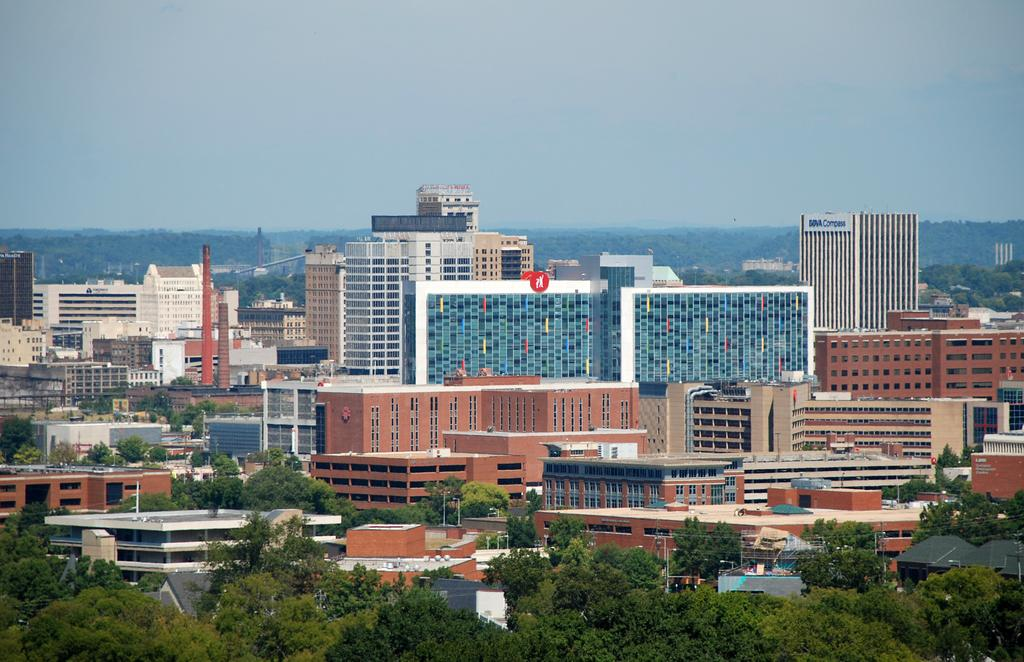What type of landscape is depicted in the image? The image contains a view of the city. What is a common feature of the buildings in the city? There are many glass buildings in the image. What type of vegetation can be seen in the image? There are trees in the front side of the image. How many veins can be seen running through the trees in the image? There are no veins visible in the image, as veins are a part of living organisms and not visible in trees. 